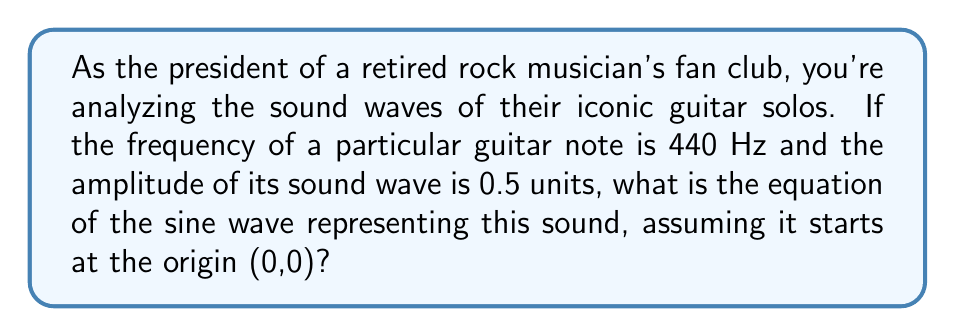Show me your answer to this math problem. Let's approach this step-by-step:

1) The general equation for a sine wave is:

   $$y = A \sin(2\pi ft + \phi)$$

   Where:
   $A$ = amplitude
   $f$ = frequency
   $t$ = time
   $\phi$ = phase shift

2) We're given:
   Amplitude ($A$) = 0.5 units
   Frequency ($f$) = 440 Hz

3) Since the wave starts at the origin (0,0), there's no phase shift, so $\phi = 0$.

4) Substituting these values into our equation:

   $$y = 0.5 \sin(2\pi(440)t)$$

5) Simplify the constant inside the parentheses:

   $$y = 0.5 \sin(880\pi t)$$

This is our final equation representing the sound wave of the guitar note.
Answer: $y = 0.5 \sin(880\pi t)$ 